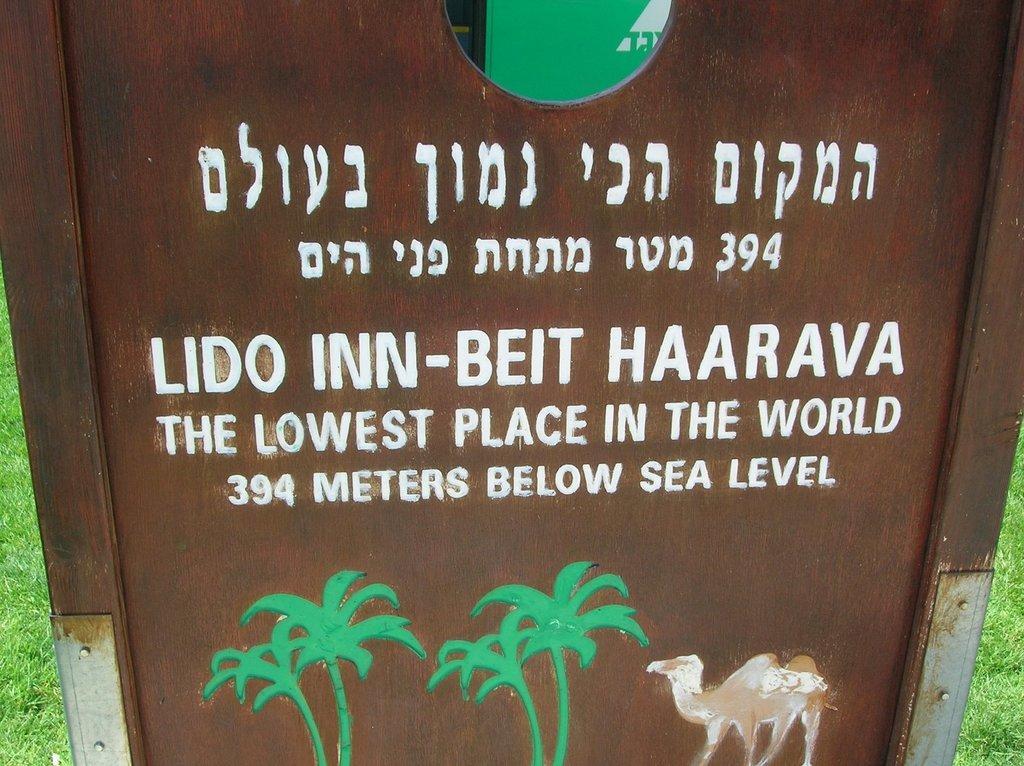Can you describe this image briefly? This is a zoomed in picture. In the center there is a brown color board on which we can see the picture of a camel and the trees and the the text is printed on the board. In the background we can see the green grass. 